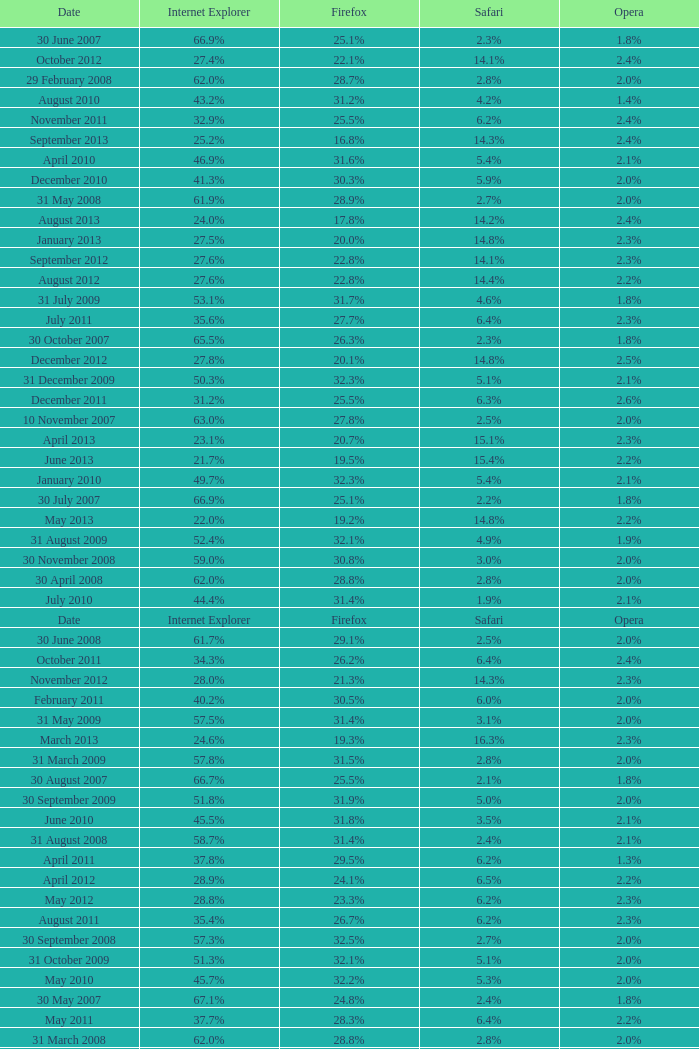What is the firefox value with a 1.9% safari? 31.4%. 